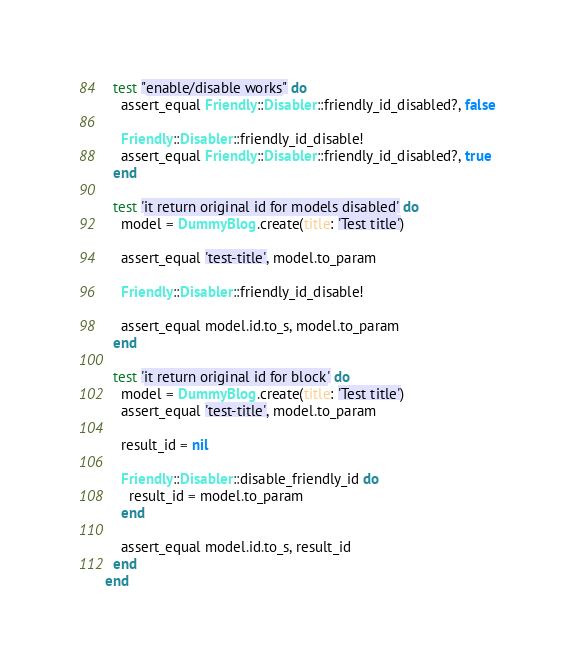<code> <loc_0><loc_0><loc_500><loc_500><_Ruby_>  test "enable/disable works" do
    assert_equal Friendly::Disabler::friendly_id_disabled?, false

    Friendly::Disabler::friendly_id_disable!
    assert_equal Friendly::Disabler::friendly_id_disabled?, true
  end

  test 'it return original id for models disabled' do
    model = DummyBlog.create(title: 'Test title')

    assert_equal 'test-title', model.to_param

    Friendly::Disabler::friendly_id_disable!

    assert_equal model.id.to_s, model.to_param
  end

  test 'it return original id for block' do
    model = DummyBlog.create(title: 'Test title')
    assert_equal 'test-title', model.to_param

    result_id = nil

    Friendly::Disabler::disable_friendly_id do
      result_id = model.to_param
    end

    assert_equal model.id.to_s, result_id
  end
end
</code> 